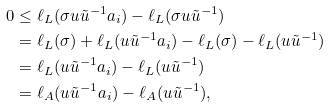Convert formula to latex. <formula><loc_0><loc_0><loc_500><loc_500>0 & \leq \ell _ { L } ( \sigma u \tilde { u } ^ { - 1 } a _ { i } ) - \ell _ { L } ( \sigma u \tilde { u } ^ { - 1 } ) \\ & = \ell _ { L } ( \sigma ) + \ell _ { L } ( u \tilde { u } ^ { - 1 } a _ { i } ) - \ell _ { L } ( \sigma ) - \ell _ { L } ( u \tilde { u } ^ { - 1 } ) \\ & = \ell _ { L } ( u \tilde { u } ^ { - 1 } a _ { i } ) - \ell _ { L } ( u \tilde { u } ^ { - 1 } ) \\ & = \ell _ { A } ( u \tilde { u } ^ { - 1 } a _ { i } ) - \ell _ { A } ( u \tilde { u } ^ { - 1 } ) ,</formula> 